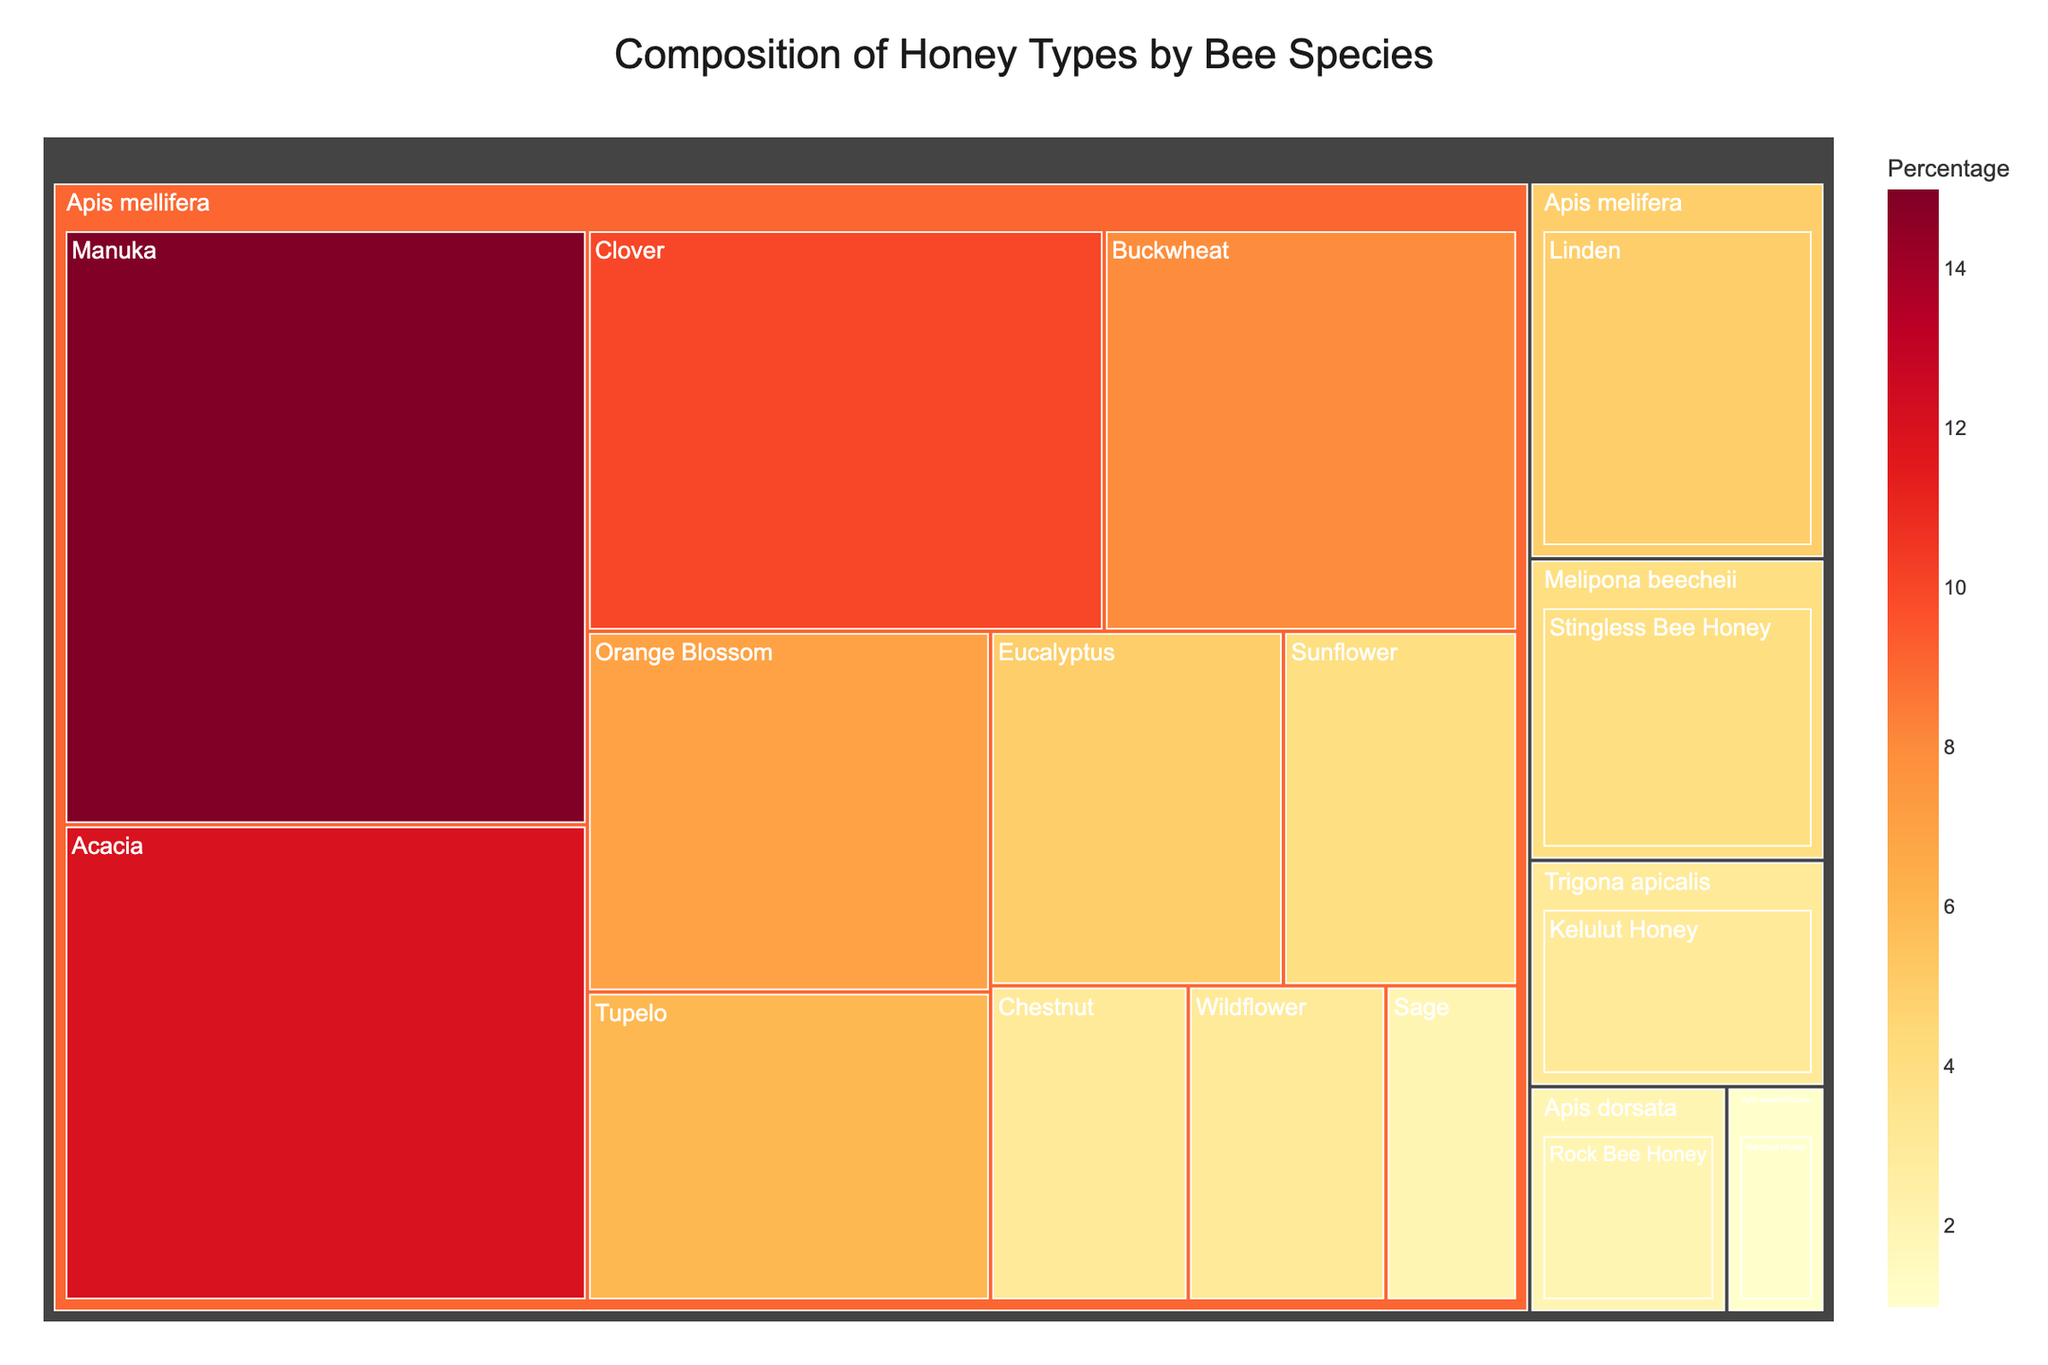What is the title of the treemap? The title is usually located at the top of the figure and provides an overview of what the chart represents. Here, the title is clearly stated.
Answer: Composition of Honey Types by Bee Species Which honey type produced by Apis mellifera has the highest percentage? To answer this, we look at the section in the treemap under "Apis mellifera" with the largest size, indicating the highest percentage.
Answer: Manuka What is the sum of the percentages for honey types produced by species other than Apis mellifera? Add the percentages of honey types produced by Melipona beecheii (4%), Trigona apicalis (3%), Apis dorsata (2%), and Apis andreniformis (1%). The total is 4% + 3% + 2% + 1% = 10%.
Answer: 10% Which bee species produces the most diverse types of honey, and how many types do they produce? To find this, count the number of different honey types listed under each bee species. Apis mellifera has the most types listed.
Answer: Apis mellifera produces 12 types of honey Compare the percentage of Acacia honey to Tupelo honey produced by Apis mellifera. Which is higher? Observe the sizes of the sections for Acacia and Tupelo honey under Apis mellifera. Acacia has a larger section representing 12%, while Tupelo is 6%.
Answer: Acacia honey is higher What is the combined percentage of Manuka and Buckwheat honey produced by Apis mellifera? Add the percentage values for Manuka (15%) and Buckwheat (8%) honey under Apis mellifera. The total is 15% + 8% = 23%.
Answer: 23% Which honey type has the lowest percentage and which bee species produces it? Identify the smallest section in the treemap, which represents the lowest percentage. Here it is Bamboo Honey produced by Apis andreniformis with 1%.
Answer: Bamboo Honey by Apis andreniformis What is the average percentage of the six most prevalent honey types produced by Apis mellifera? Identify the six largest percentages under Apis mellifera: 15% (Manuka), 12% (Acacia), 10% (Clover), 8% (Buckwheat), 7% (Orange Blossom), and 6% (Tupelo). Sum these values and divide by 6. The sum is 15 + 12 + 10 + 8 + 7 + 6 = 58, and the average is 58/6 = 9.67%.
Answer: 9.67% Which two honey types produced by Apis mellifera have the same percentage? Look for sections in the treemap under Apis mellifera that have equal sizes, representing the same percentages. Here, Linden and Eucalyptus both have a percentage of 5%.
Answer: Linden and Eucalyptus How does the percentage of Wildflower honey compare to Sage honey produced by Apis mellifera? Compare the sizes of the sections for Wildflower and Sage honey under Apis mellifera. Wildflower has 3%, while Sage has 2%.
Answer: Wildflower honey has a higher percentage than Sage honey 